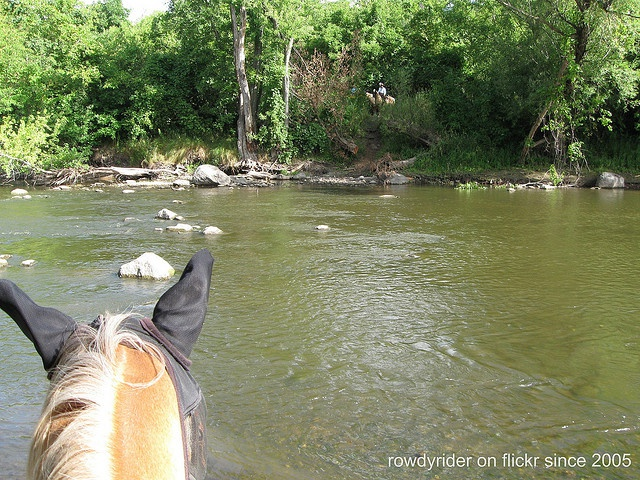Describe the objects in this image and their specific colors. I can see horse in khaki, ivory, tan, gray, and darkgray tones, horse in khaki, black, darkgreen, gray, and tan tones, and people in khaki, white, black, gray, and darkgreen tones in this image. 